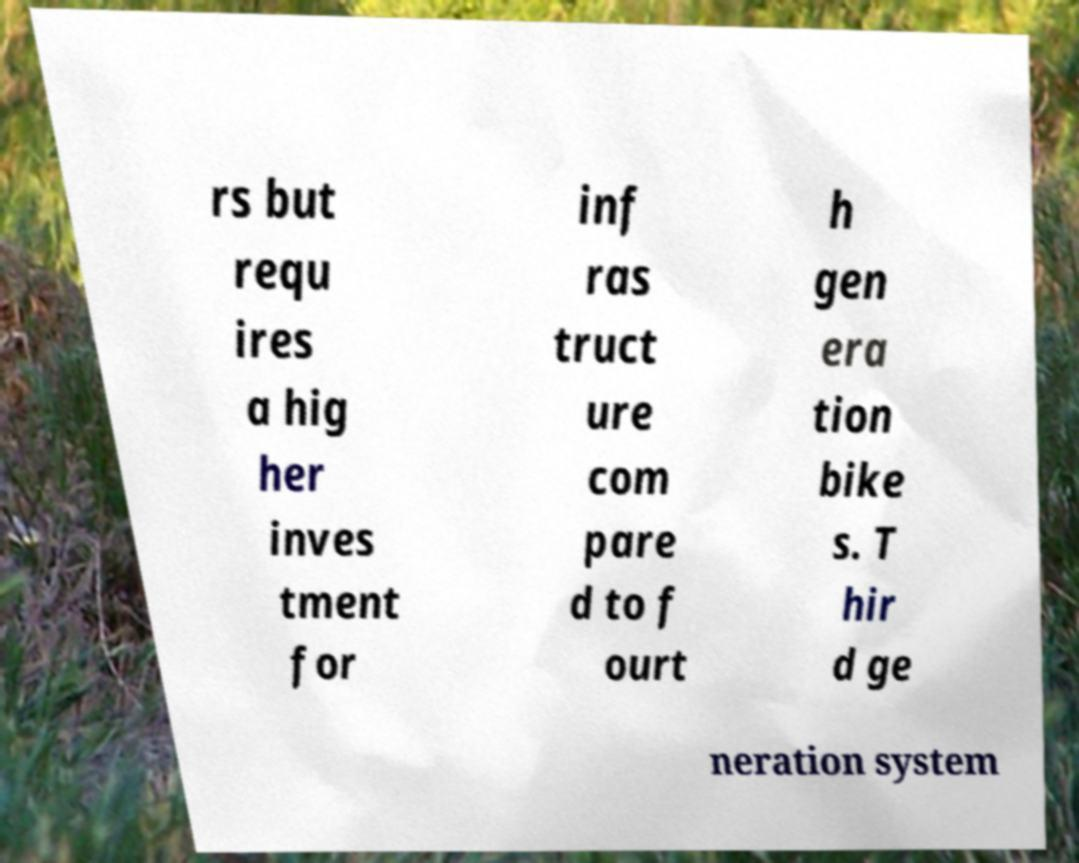Could you extract and type out the text from this image? rs but requ ires a hig her inves tment for inf ras truct ure com pare d to f ourt h gen era tion bike s. T hir d ge neration system 